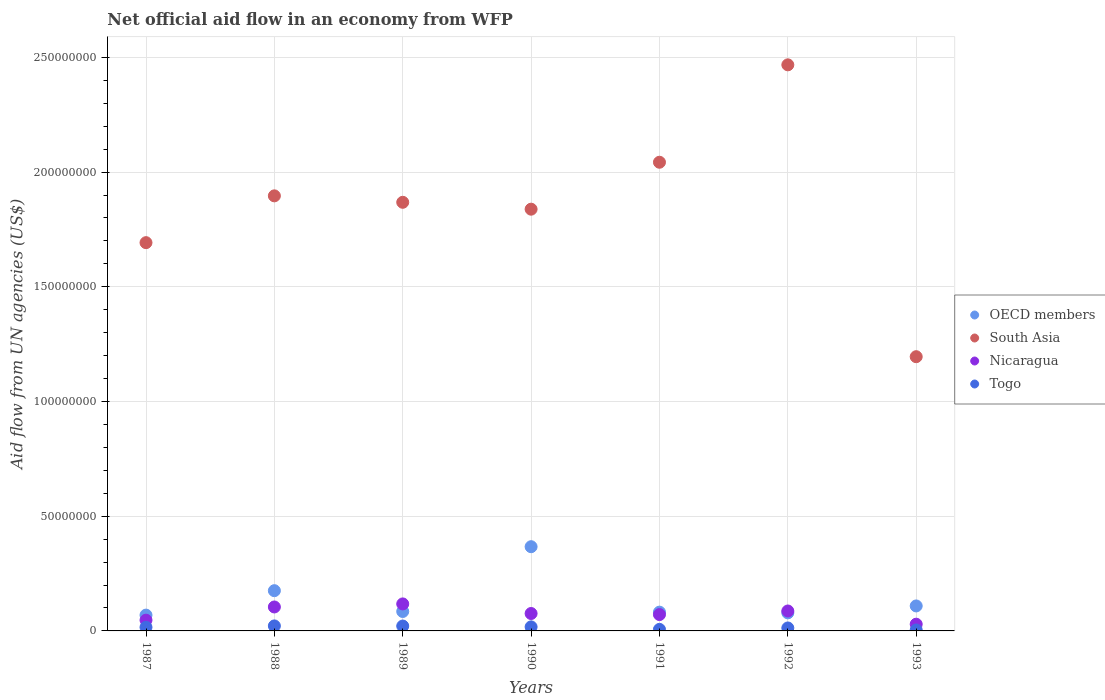What is the net official aid flow in South Asia in 1991?
Provide a short and direct response. 2.04e+08. Across all years, what is the maximum net official aid flow in South Asia?
Your answer should be compact. 2.47e+08. Across all years, what is the minimum net official aid flow in South Asia?
Give a very brief answer. 1.20e+08. In which year was the net official aid flow in Nicaragua maximum?
Your answer should be very brief. 1989. In which year was the net official aid flow in Togo minimum?
Ensure brevity in your answer.  1993. What is the total net official aid flow in Togo in the graph?
Provide a succinct answer. 1.00e+07. What is the difference between the net official aid flow in South Asia in 1988 and that in 1990?
Keep it short and to the point. 5.81e+06. What is the difference between the net official aid flow in Nicaragua in 1992 and the net official aid flow in South Asia in 1990?
Offer a terse response. -1.75e+08. What is the average net official aid flow in OECD members per year?
Give a very brief answer. 1.38e+07. In the year 1990, what is the difference between the net official aid flow in South Asia and net official aid flow in Togo?
Provide a succinct answer. 1.82e+08. What is the ratio of the net official aid flow in Nicaragua in 1989 to that in 1991?
Give a very brief answer. 1.65. Is the net official aid flow in South Asia in 1989 less than that in 1991?
Provide a short and direct response. Yes. What is the difference between the highest and the second highest net official aid flow in OECD members?
Provide a succinct answer. 1.92e+07. What is the difference between the highest and the lowest net official aid flow in Nicaragua?
Give a very brief answer. 8.84e+06. Is the sum of the net official aid flow in OECD members in 1987 and 1991 greater than the maximum net official aid flow in Togo across all years?
Offer a terse response. Yes. Is it the case that in every year, the sum of the net official aid flow in Togo and net official aid flow in OECD members  is greater than the sum of net official aid flow in South Asia and net official aid flow in Nicaragua?
Keep it short and to the point. Yes. Is it the case that in every year, the sum of the net official aid flow in OECD members and net official aid flow in South Asia  is greater than the net official aid flow in Nicaragua?
Ensure brevity in your answer.  Yes. Is the net official aid flow in OECD members strictly greater than the net official aid flow in Togo over the years?
Ensure brevity in your answer.  Yes. How many dotlines are there?
Your response must be concise. 4. How many years are there in the graph?
Make the answer very short. 7. What is the difference between two consecutive major ticks on the Y-axis?
Offer a terse response. 5.00e+07. Does the graph contain any zero values?
Offer a very short reply. No. Does the graph contain grids?
Make the answer very short. Yes. Where does the legend appear in the graph?
Provide a succinct answer. Center right. How many legend labels are there?
Provide a succinct answer. 4. How are the legend labels stacked?
Ensure brevity in your answer.  Vertical. What is the title of the graph?
Offer a terse response. Net official aid flow in an economy from WFP. Does "Bosnia and Herzegovina" appear as one of the legend labels in the graph?
Your answer should be compact. No. What is the label or title of the Y-axis?
Offer a very short reply. Aid flow from UN agencies (US$). What is the Aid flow from UN agencies (US$) of OECD members in 1987?
Offer a very short reply. 6.89e+06. What is the Aid flow from UN agencies (US$) in South Asia in 1987?
Your answer should be compact. 1.69e+08. What is the Aid flow from UN agencies (US$) in Nicaragua in 1987?
Provide a short and direct response. 4.69e+06. What is the Aid flow from UN agencies (US$) of Togo in 1987?
Provide a short and direct response. 1.59e+06. What is the Aid flow from UN agencies (US$) in OECD members in 1988?
Give a very brief answer. 1.75e+07. What is the Aid flow from UN agencies (US$) in South Asia in 1988?
Make the answer very short. 1.90e+08. What is the Aid flow from UN agencies (US$) in Nicaragua in 1988?
Offer a terse response. 1.04e+07. What is the Aid flow from UN agencies (US$) in Togo in 1988?
Give a very brief answer. 2.18e+06. What is the Aid flow from UN agencies (US$) in OECD members in 1989?
Your response must be concise. 8.47e+06. What is the Aid flow from UN agencies (US$) of South Asia in 1989?
Ensure brevity in your answer.  1.87e+08. What is the Aid flow from UN agencies (US$) of Nicaragua in 1989?
Ensure brevity in your answer.  1.18e+07. What is the Aid flow from UN agencies (US$) of Togo in 1989?
Provide a short and direct response. 2.13e+06. What is the Aid flow from UN agencies (US$) of OECD members in 1990?
Provide a short and direct response. 3.67e+07. What is the Aid flow from UN agencies (US$) of South Asia in 1990?
Provide a short and direct response. 1.84e+08. What is the Aid flow from UN agencies (US$) of Nicaragua in 1990?
Give a very brief answer. 7.59e+06. What is the Aid flow from UN agencies (US$) of Togo in 1990?
Provide a succinct answer. 1.76e+06. What is the Aid flow from UN agencies (US$) of OECD members in 1991?
Your answer should be compact. 8.18e+06. What is the Aid flow from UN agencies (US$) of South Asia in 1991?
Your answer should be compact. 2.04e+08. What is the Aid flow from UN agencies (US$) in Nicaragua in 1991?
Offer a terse response. 7.13e+06. What is the Aid flow from UN agencies (US$) in Togo in 1991?
Provide a succinct answer. 6.70e+05. What is the Aid flow from UN agencies (US$) of OECD members in 1992?
Provide a short and direct response. 7.87e+06. What is the Aid flow from UN agencies (US$) in South Asia in 1992?
Offer a terse response. 2.47e+08. What is the Aid flow from UN agencies (US$) of Nicaragua in 1992?
Give a very brief answer. 8.69e+06. What is the Aid flow from UN agencies (US$) of Togo in 1992?
Your response must be concise. 1.29e+06. What is the Aid flow from UN agencies (US$) in OECD members in 1993?
Your answer should be compact. 1.09e+07. What is the Aid flow from UN agencies (US$) in South Asia in 1993?
Your answer should be compact. 1.20e+08. What is the Aid flow from UN agencies (US$) in Nicaragua in 1993?
Your answer should be compact. 2.93e+06. What is the Aid flow from UN agencies (US$) of Togo in 1993?
Your answer should be compact. 4.20e+05. Across all years, what is the maximum Aid flow from UN agencies (US$) of OECD members?
Your answer should be very brief. 3.67e+07. Across all years, what is the maximum Aid flow from UN agencies (US$) in South Asia?
Ensure brevity in your answer.  2.47e+08. Across all years, what is the maximum Aid flow from UN agencies (US$) of Nicaragua?
Provide a short and direct response. 1.18e+07. Across all years, what is the maximum Aid flow from UN agencies (US$) in Togo?
Make the answer very short. 2.18e+06. Across all years, what is the minimum Aid flow from UN agencies (US$) in OECD members?
Provide a succinct answer. 6.89e+06. Across all years, what is the minimum Aid flow from UN agencies (US$) of South Asia?
Keep it short and to the point. 1.20e+08. Across all years, what is the minimum Aid flow from UN agencies (US$) in Nicaragua?
Provide a succinct answer. 2.93e+06. Across all years, what is the minimum Aid flow from UN agencies (US$) of Togo?
Your answer should be compact. 4.20e+05. What is the total Aid flow from UN agencies (US$) in OECD members in the graph?
Make the answer very short. 9.66e+07. What is the total Aid flow from UN agencies (US$) of South Asia in the graph?
Provide a short and direct response. 1.30e+09. What is the total Aid flow from UN agencies (US$) of Nicaragua in the graph?
Keep it short and to the point. 5.32e+07. What is the total Aid flow from UN agencies (US$) of Togo in the graph?
Your answer should be very brief. 1.00e+07. What is the difference between the Aid flow from UN agencies (US$) of OECD members in 1987 and that in 1988?
Your response must be concise. -1.06e+07. What is the difference between the Aid flow from UN agencies (US$) in South Asia in 1987 and that in 1988?
Offer a very short reply. -2.04e+07. What is the difference between the Aid flow from UN agencies (US$) in Nicaragua in 1987 and that in 1988?
Provide a succinct answer. -5.75e+06. What is the difference between the Aid flow from UN agencies (US$) in Togo in 1987 and that in 1988?
Make the answer very short. -5.90e+05. What is the difference between the Aid flow from UN agencies (US$) in OECD members in 1987 and that in 1989?
Ensure brevity in your answer.  -1.58e+06. What is the difference between the Aid flow from UN agencies (US$) in South Asia in 1987 and that in 1989?
Provide a succinct answer. -1.76e+07. What is the difference between the Aid flow from UN agencies (US$) in Nicaragua in 1987 and that in 1989?
Your answer should be compact. -7.08e+06. What is the difference between the Aid flow from UN agencies (US$) of Togo in 1987 and that in 1989?
Provide a short and direct response. -5.40e+05. What is the difference between the Aid flow from UN agencies (US$) of OECD members in 1987 and that in 1990?
Ensure brevity in your answer.  -2.98e+07. What is the difference between the Aid flow from UN agencies (US$) of South Asia in 1987 and that in 1990?
Your answer should be very brief. -1.46e+07. What is the difference between the Aid flow from UN agencies (US$) of Nicaragua in 1987 and that in 1990?
Provide a succinct answer. -2.90e+06. What is the difference between the Aid flow from UN agencies (US$) of Togo in 1987 and that in 1990?
Your answer should be compact. -1.70e+05. What is the difference between the Aid flow from UN agencies (US$) of OECD members in 1987 and that in 1991?
Provide a short and direct response. -1.29e+06. What is the difference between the Aid flow from UN agencies (US$) of South Asia in 1987 and that in 1991?
Your answer should be very brief. -3.50e+07. What is the difference between the Aid flow from UN agencies (US$) in Nicaragua in 1987 and that in 1991?
Offer a terse response. -2.44e+06. What is the difference between the Aid flow from UN agencies (US$) in Togo in 1987 and that in 1991?
Provide a succinct answer. 9.20e+05. What is the difference between the Aid flow from UN agencies (US$) of OECD members in 1987 and that in 1992?
Give a very brief answer. -9.80e+05. What is the difference between the Aid flow from UN agencies (US$) of South Asia in 1987 and that in 1992?
Provide a succinct answer. -7.75e+07. What is the difference between the Aid flow from UN agencies (US$) of Nicaragua in 1987 and that in 1992?
Offer a terse response. -4.00e+06. What is the difference between the Aid flow from UN agencies (US$) of South Asia in 1987 and that in 1993?
Your answer should be compact. 4.97e+07. What is the difference between the Aid flow from UN agencies (US$) in Nicaragua in 1987 and that in 1993?
Keep it short and to the point. 1.76e+06. What is the difference between the Aid flow from UN agencies (US$) of Togo in 1987 and that in 1993?
Keep it short and to the point. 1.17e+06. What is the difference between the Aid flow from UN agencies (US$) in OECD members in 1988 and that in 1989?
Provide a succinct answer. 9.07e+06. What is the difference between the Aid flow from UN agencies (US$) in South Asia in 1988 and that in 1989?
Offer a very short reply. 2.81e+06. What is the difference between the Aid flow from UN agencies (US$) in Nicaragua in 1988 and that in 1989?
Offer a terse response. -1.33e+06. What is the difference between the Aid flow from UN agencies (US$) in OECD members in 1988 and that in 1990?
Offer a terse response. -1.92e+07. What is the difference between the Aid flow from UN agencies (US$) in South Asia in 1988 and that in 1990?
Your answer should be compact. 5.81e+06. What is the difference between the Aid flow from UN agencies (US$) in Nicaragua in 1988 and that in 1990?
Keep it short and to the point. 2.85e+06. What is the difference between the Aid flow from UN agencies (US$) in Togo in 1988 and that in 1990?
Your answer should be very brief. 4.20e+05. What is the difference between the Aid flow from UN agencies (US$) in OECD members in 1988 and that in 1991?
Offer a very short reply. 9.36e+06. What is the difference between the Aid flow from UN agencies (US$) in South Asia in 1988 and that in 1991?
Make the answer very short. -1.46e+07. What is the difference between the Aid flow from UN agencies (US$) in Nicaragua in 1988 and that in 1991?
Ensure brevity in your answer.  3.31e+06. What is the difference between the Aid flow from UN agencies (US$) in Togo in 1988 and that in 1991?
Make the answer very short. 1.51e+06. What is the difference between the Aid flow from UN agencies (US$) in OECD members in 1988 and that in 1992?
Make the answer very short. 9.67e+06. What is the difference between the Aid flow from UN agencies (US$) in South Asia in 1988 and that in 1992?
Ensure brevity in your answer.  -5.71e+07. What is the difference between the Aid flow from UN agencies (US$) in Nicaragua in 1988 and that in 1992?
Your answer should be very brief. 1.75e+06. What is the difference between the Aid flow from UN agencies (US$) of Togo in 1988 and that in 1992?
Give a very brief answer. 8.90e+05. What is the difference between the Aid flow from UN agencies (US$) in OECD members in 1988 and that in 1993?
Offer a very short reply. 6.65e+06. What is the difference between the Aid flow from UN agencies (US$) of South Asia in 1988 and that in 1993?
Your answer should be very brief. 7.01e+07. What is the difference between the Aid flow from UN agencies (US$) of Nicaragua in 1988 and that in 1993?
Give a very brief answer. 7.51e+06. What is the difference between the Aid flow from UN agencies (US$) in Togo in 1988 and that in 1993?
Offer a terse response. 1.76e+06. What is the difference between the Aid flow from UN agencies (US$) of OECD members in 1989 and that in 1990?
Your answer should be very brief. -2.82e+07. What is the difference between the Aid flow from UN agencies (US$) of Nicaragua in 1989 and that in 1990?
Provide a short and direct response. 4.18e+06. What is the difference between the Aid flow from UN agencies (US$) of Togo in 1989 and that in 1990?
Offer a very short reply. 3.70e+05. What is the difference between the Aid flow from UN agencies (US$) in South Asia in 1989 and that in 1991?
Keep it short and to the point. -1.75e+07. What is the difference between the Aid flow from UN agencies (US$) in Nicaragua in 1989 and that in 1991?
Your response must be concise. 4.64e+06. What is the difference between the Aid flow from UN agencies (US$) in Togo in 1989 and that in 1991?
Your response must be concise. 1.46e+06. What is the difference between the Aid flow from UN agencies (US$) in South Asia in 1989 and that in 1992?
Your answer should be compact. -5.99e+07. What is the difference between the Aid flow from UN agencies (US$) of Nicaragua in 1989 and that in 1992?
Ensure brevity in your answer.  3.08e+06. What is the difference between the Aid flow from UN agencies (US$) in Togo in 1989 and that in 1992?
Your answer should be very brief. 8.40e+05. What is the difference between the Aid flow from UN agencies (US$) of OECD members in 1989 and that in 1993?
Offer a terse response. -2.42e+06. What is the difference between the Aid flow from UN agencies (US$) in South Asia in 1989 and that in 1993?
Your response must be concise. 6.73e+07. What is the difference between the Aid flow from UN agencies (US$) in Nicaragua in 1989 and that in 1993?
Your answer should be very brief. 8.84e+06. What is the difference between the Aid flow from UN agencies (US$) of Togo in 1989 and that in 1993?
Give a very brief answer. 1.71e+06. What is the difference between the Aid flow from UN agencies (US$) of OECD members in 1990 and that in 1991?
Provide a short and direct response. 2.85e+07. What is the difference between the Aid flow from UN agencies (US$) of South Asia in 1990 and that in 1991?
Keep it short and to the point. -2.05e+07. What is the difference between the Aid flow from UN agencies (US$) of Nicaragua in 1990 and that in 1991?
Provide a succinct answer. 4.60e+05. What is the difference between the Aid flow from UN agencies (US$) of Togo in 1990 and that in 1991?
Provide a short and direct response. 1.09e+06. What is the difference between the Aid flow from UN agencies (US$) in OECD members in 1990 and that in 1992?
Keep it short and to the point. 2.88e+07. What is the difference between the Aid flow from UN agencies (US$) of South Asia in 1990 and that in 1992?
Your answer should be very brief. -6.29e+07. What is the difference between the Aid flow from UN agencies (US$) of Nicaragua in 1990 and that in 1992?
Provide a succinct answer. -1.10e+06. What is the difference between the Aid flow from UN agencies (US$) in Togo in 1990 and that in 1992?
Provide a short and direct response. 4.70e+05. What is the difference between the Aid flow from UN agencies (US$) of OECD members in 1990 and that in 1993?
Your answer should be very brief. 2.58e+07. What is the difference between the Aid flow from UN agencies (US$) in South Asia in 1990 and that in 1993?
Your answer should be compact. 6.43e+07. What is the difference between the Aid flow from UN agencies (US$) of Nicaragua in 1990 and that in 1993?
Make the answer very short. 4.66e+06. What is the difference between the Aid flow from UN agencies (US$) of Togo in 1990 and that in 1993?
Make the answer very short. 1.34e+06. What is the difference between the Aid flow from UN agencies (US$) in OECD members in 1991 and that in 1992?
Offer a very short reply. 3.10e+05. What is the difference between the Aid flow from UN agencies (US$) of South Asia in 1991 and that in 1992?
Give a very brief answer. -4.25e+07. What is the difference between the Aid flow from UN agencies (US$) of Nicaragua in 1991 and that in 1992?
Keep it short and to the point. -1.56e+06. What is the difference between the Aid flow from UN agencies (US$) of Togo in 1991 and that in 1992?
Offer a very short reply. -6.20e+05. What is the difference between the Aid flow from UN agencies (US$) in OECD members in 1991 and that in 1993?
Provide a succinct answer. -2.71e+06. What is the difference between the Aid flow from UN agencies (US$) of South Asia in 1991 and that in 1993?
Offer a very short reply. 8.48e+07. What is the difference between the Aid flow from UN agencies (US$) of Nicaragua in 1991 and that in 1993?
Make the answer very short. 4.20e+06. What is the difference between the Aid flow from UN agencies (US$) in Togo in 1991 and that in 1993?
Offer a very short reply. 2.50e+05. What is the difference between the Aid flow from UN agencies (US$) of OECD members in 1992 and that in 1993?
Provide a short and direct response. -3.02e+06. What is the difference between the Aid flow from UN agencies (US$) in South Asia in 1992 and that in 1993?
Make the answer very short. 1.27e+08. What is the difference between the Aid flow from UN agencies (US$) in Nicaragua in 1992 and that in 1993?
Give a very brief answer. 5.76e+06. What is the difference between the Aid flow from UN agencies (US$) in Togo in 1992 and that in 1993?
Your response must be concise. 8.70e+05. What is the difference between the Aid flow from UN agencies (US$) in OECD members in 1987 and the Aid flow from UN agencies (US$) in South Asia in 1988?
Ensure brevity in your answer.  -1.83e+08. What is the difference between the Aid flow from UN agencies (US$) in OECD members in 1987 and the Aid flow from UN agencies (US$) in Nicaragua in 1988?
Your answer should be very brief. -3.55e+06. What is the difference between the Aid flow from UN agencies (US$) in OECD members in 1987 and the Aid flow from UN agencies (US$) in Togo in 1988?
Your answer should be compact. 4.71e+06. What is the difference between the Aid flow from UN agencies (US$) in South Asia in 1987 and the Aid flow from UN agencies (US$) in Nicaragua in 1988?
Offer a very short reply. 1.59e+08. What is the difference between the Aid flow from UN agencies (US$) of South Asia in 1987 and the Aid flow from UN agencies (US$) of Togo in 1988?
Give a very brief answer. 1.67e+08. What is the difference between the Aid flow from UN agencies (US$) of Nicaragua in 1987 and the Aid flow from UN agencies (US$) of Togo in 1988?
Give a very brief answer. 2.51e+06. What is the difference between the Aid flow from UN agencies (US$) in OECD members in 1987 and the Aid flow from UN agencies (US$) in South Asia in 1989?
Your response must be concise. -1.80e+08. What is the difference between the Aid flow from UN agencies (US$) in OECD members in 1987 and the Aid flow from UN agencies (US$) in Nicaragua in 1989?
Provide a succinct answer. -4.88e+06. What is the difference between the Aid flow from UN agencies (US$) in OECD members in 1987 and the Aid flow from UN agencies (US$) in Togo in 1989?
Ensure brevity in your answer.  4.76e+06. What is the difference between the Aid flow from UN agencies (US$) of South Asia in 1987 and the Aid flow from UN agencies (US$) of Nicaragua in 1989?
Your response must be concise. 1.57e+08. What is the difference between the Aid flow from UN agencies (US$) of South Asia in 1987 and the Aid flow from UN agencies (US$) of Togo in 1989?
Provide a succinct answer. 1.67e+08. What is the difference between the Aid flow from UN agencies (US$) of Nicaragua in 1987 and the Aid flow from UN agencies (US$) of Togo in 1989?
Provide a short and direct response. 2.56e+06. What is the difference between the Aid flow from UN agencies (US$) of OECD members in 1987 and the Aid flow from UN agencies (US$) of South Asia in 1990?
Give a very brief answer. -1.77e+08. What is the difference between the Aid flow from UN agencies (US$) in OECD members in 1987 and the Aid flow from UN agencies (US$) in Nicaragua in 1990?
Make the answer very short. -7.00e+05. What is the difference between the Aid flow from UN agencies (US$) in OECD members in 1987 and the Aid flow from UN agencies (US$) in Togo in 1990?
Your answer should be compact. 5.13e+06. What is the difference between the Aid flow from UN agencies (US$) in South Asia in 1987 and the Aid flow from UN agencies (US$) in Nicaragua in 1990?
Provide a short and direct response. 1.62e+08. What is the difference between the Aid flow from UN agencies (US$) of South Asia in 1987 and the Aid flow from UN agencies (US$) of Togo in 1990?
Your answer should be compact. 1.67e+08. What is the difference between the Aid flow from UN agencies (US$) of Nicaragua in 1987 and the Aid flow from UN agencies (US$) of Togo in 1990?
Offer a terse response. 2.93e+06. What is the difference between the Aid flow from UN agencies (US$) of OECD members in 1987 and the Aid flow from UN agencies (US$) of South Asia in 1991?
Keep it short and to the point. -1.97e+08. What is the difference between the Aid flow from UN agencies (US$) in OECD members in 1987 and the Aid flow from UN agencies (US$) in Togo in 1991?
Make the answer very short. 6.22e+06. What is the difference between the Aid flow from UN agencies (US$) in South Asia in 1987 and the Aid flow from UN agencies (US$) in Nicaragua in 1991?
Offer a very short reply. 1.62e+08. What is the difference between the Aid flow from UN agencies (US$) of South Asia in 1987 and the Aid flow from UN agencies (US$) of Togo in 1991?
Give a very brief answer. 1.69e+08. What is the difference between the Aid flow from UN agencies (US$) of Nicaragua in 1987 and the Aid flow from UN agencies (US$) of Togo in 1991?
Keep it short and to the point. 4.02e+06. What is the difference between the Aid flow from UN agencies (US$) in OECD members in 1987 and the Aid flow from UN agencies (US$) in South Asia in 1992?
Give a very brief answer. -2.40e+08. What is the difference between the Aid flow from UN agencies (US$) in OECD members in 1987 and the Aid flow from UN agencies (US$) in Nicaragua in 1992?
Keep it short and to the point. -1.80e+06. What is the difference between the Aid flow from UN agencies (US$) of OECD members in 1987 and the Aid flow from UN agencies (US$) of Togo in 1992?
Ensure brevity in your answer.  5.60e+06. What is the difference between the Aid flow from UN agencies (US$) in South Asia in 1987 and the Aid flow from UN agencies (US$) in Nicaragua in 1992?
Your answer should be very brief. 1.61e+08. What is the difference between the Aid flow from UN agencies (US$) in South Asia in 1987 and the Aid flow from UN agencies (US$) in Togo in 1992?
Make the answer very short. 1.68e+08. What is the difference between the Aid flow from UN agencies (US$) in Nicaragua in 1987 and the Aid flow from UN agencies (US$) in Togo in 1992?
Give a very brief answer. 3.40e+06. What is the difference between the Aid flow from UN agencies (US$) of OECD members in 1987 and the Aid flow from UN agencies (US$) of South Asia in 1993?
Provide a succinct answer. -1.13e+08. What is the difference between the Aid flow from UN agencies (US$) in OECD members in 1987 and the Aid flow from UN agencies (US$) in Nicaragua in 1993?
Provide a succinct answer. 3.96e+06. What is the difference between the Aid flow from UN agencies (US$) in OECD members in 1987 and the Aid flow from UN agencies (US$) in Togo in 1993?
Ensure brevity in your answer.  6.47e+06. What is the difference between the Aid flow from UN agencies (US$) in South Asia in 1987 and the Aid flow from UN agencies (US$) in Nicaragua in 1993?
Make the answer very short. 1.66e+08. What is the difference between the Aid flow from UN agencies (US$) in South Asia in 1987 and the Aid flow from UN agencies (US$) in Togo in 1993?
Provide a short and direct response. 1.69e+08. What is the difference between the Aid flow from UN agencies (US$) in Nicaragua in 1987 and the Aid flow from UN agencies (US$) in Togo in 1993?
Provide a short and direct response. 4.27e+06. What is the difference between the Aid flow from UN agencies (US$) in OECD members in 1988 and the Aid flow from UN agencies (US$) in South Asia in 1989?
Give a very brief answer. -1.69e+08. What is the difference between the Aid flow from UN agencies (US$) in OECD members in 1988 and the Aid flow from UN agencies (US$) in Nicaragua in 1989?
Your response must be concise. 5.77e+06. What is the difference between the Aid flow from UN agencies (US$) of OECD members in 1988 and the Aid flow from UN agencies (US$) of Togo in 1989?
Your answer should be compact. 1.54e+07. What is the difference between the Aid flow from UN agencies (US$) in South Asia in 1988 and the Aid flow from UN agencies (US$) in Nicaragua in 1989?
Keep it short and to the point. 1.78e+08. What is the difference between the Aid flow from UN agencies (US$) of South Asia in 1988 and the Aid flow from UN agencies (US$) of Togo in 1989?
Keep it short and to the point. 1.88e+08. What is the difference between the Aid flow from UN agencies (US$) of Nicaragua in 1988 and the Aid flow from UN agencies (US$) of Togo in 1989?
Keep it short and to the point. 8.31e+06. What is the difference between the Aid flow from UN agencies (US$) in OECD members in 1988 and the Aid flow from UN agencies (US$) in South Asia in 1990?
Give a very brief answer. -1.66e+08. What is the difference between the Aid flow from UN agencies (US$) of OECD members in 1988 and the Aid flow from UN agencies (US$) of Nicaragua in 1990?
Keep it short and to the point. 9.95e+06. What is the difference between the Aid flow from UN agencies (US$) of OECD members in 1988 and the Aid flow from UN agencies (US$) of Togo in 1990?
Keep it short and to the point. 1.58e+07. What is the difference between the Aid flow from UN agencies (US$) in South Asia in 1988 and the Aid flow from UN agencies (US$) in Nicaragua in 1990?
Keep it short and to the point. 1.82e+08. What is the difference between the Aid flow from UN agencies (US$) of South Asia in 1988 and the Aid flow from UN agencies (US$) of Togo in 1990?
Offer a terse response. 1.88e+08. What is the difference between the Aid flow from UN agencies (US$) of Nicaragua in 1988 and the Aid flow from UN agencies (US$) of Togo in 1990?
Your response must be concise. 8.68e+06. What is the difference between the Aid flow from UN agencies (US$) in OECD members in 1988 and the Aid flow from UN agencies (US$) in South Asia in 1991?
Keep it short and to the point. -1.87e+08. What is the difference between the Aid flow from UN agencies (US$) of OECD members in 1988 and the Aid flow from UN agencies (US$) of Nicaragua in 1991?
Offer a very short reply. 1.04e+07. What is the difference between the Aid flow from UN agencies (US$) in OECD members in 1988 and the Aid flow from UN agencies (US$) in Togo in 1991?
Provide a short and direct response. 1.69e+07. What is the difference between the Aid flow from UN agencies (US$) in South Asia in 1988 and the Aid flow from UN agencies (US$) in Nicaragua in 1991?
Make the answer very short. 1.83e+08. What is the difference between the Aid flow from UN agencies (US$) in South Asia in 1988 and the Aid flow from UN agencies (US$) in Togo in 1991?
Ensure brevity in your answer.  1.89e+08. What is the difference between the Aid flow from UN agencies (US$) of Nicaragua in 1988 and the Aid flow from UN agencies (US$) of Togo in 1991?
Make the answer very short. 9.77e+06. What is the difference between the Aid flow from UN agencies (US$) in OECD members in 1988 and the Aid flow from UN agencies (US$) in South Asia in 1992?
Offer a very short reply. -2.29e+08. What is the difference between the Aid flow from UN agencies (US$) of OECD members in 1988 and the Aid flow from UN agencies (US$) of Nicaragua in 1992?
Your response must be concise. 8.85e+06. What is the difference between the Aid flow from UN agencies (US$) in OECD members in 1988 and the Aid flow from UN agencies (US$) in Togo in 1992?
Your response must be concise. 1.62e+07. What is the difference between the Aid flow from UN agencies (US$) in South Asia in 1988 and the Aid flow from UN agencies (US$) in Nicaragua in 1992?
Keep it short and to the point. 1.81e+08. What is the difference between the Aid flow from UN agencies (US$) of South Asia in 1988 and the Aid flow from UN agencies (US$) of Togo in 1992?
Give a very brief answer. 1.88e+08. What is the difference between the Aid flow from UN agencies (US$) of Nicaragua in 1988 and the Aid flow from UN agencies (US$) of Togo in 1992?
Your answer should be compact. 9.15e+06. What is the difference between the Aid flow from UN agencies (US$) of OECD members in 1988 and the Aid flow from UN agencies (US$) of South Asia in 1993?
Your answer should be very brief. -1.02e+08. What is the difference between the Aid flow from UN agencies (US$) of OECD members in 1988 and the Aid flow from UN agencies (US$) of Nicaragua in 1993?
Your answer should be very brief. 1.46e+07. What is the difference between the Aid flow from UN agencies (US$) of OECD members in 1988 and the Aid flow from UN agencies (US$) of Togo in 1993?
Provide a succinct answer. 1.71e+07. What is the difference between the Aid flow from UN agencies (US$) in South Asia in 1988 and the Aid flow from UN agencies (US$) in Nicaragua in 1993?
Keep it short and to the point. 1.87e+08. What is the difference between the Aid flow from UN agencies (US$) of South Asia in 1988 and the Aid flow from UN agencies (US$) of Togo in 1993?
Keep it short and to the point. 1.89e+08. What is the difference between the Aid flow from UN agencies (US$) of Nicaragua in 1988 and the Aid flow from UN agencies (US$) of Togo in 1993?
Your answer should be compact. 1.00e+07. What is the difference between the Aid flow from UN agencies (US$) of OECD members in 1989 and the Aid flow from UN agencies (US$) of South Asia in 1990?
Provide a succinct answer. -1.75e+08. What is the difference between the Aid flow from UN agencies (US$) of OECD members in 1989 and the Aid flow from UN agencies (US$) of Nicaragua in 1990?
Provide a short and direct response. 8.80e+05. What is the difference between the Aid flow from UN agencies (US$) of OECD members in 1989 and the Aid flow from UN agencies (US$) of Togo in 1990?
Provide a short and direct response. 6.71e+06. What is the difference between the Aid flow from UN agencies (US$) in South Asia in 1989 and the Aid flow from UN agencies (US$) in Nicaragua in 1990?
Your answer should be compact. 1.79e+08. What is the difference between the Aid flow from UN agencies (US$) in South Asia in 1989 and the Aid flow from UN agencies (US$) in Togo in 1990?
Your answer should be very brief. 1.85e+08. What is the difference between the Aid flow from UN agencies (US$) of Nicaragua in 1989 and the Aid flow from UN agencies (US$) of Togo in 1990?
Ensure brevity in your answer.  1.00e+07. What is the difference between the Aid flow from UN agencies (US$) in OECD members in 1989 and the Aid flow from UN agencies (US$) in South Asia in 1991?
Your answer should be compact. -1.96e+08. What is the difference between the Aid flow from UN agencies (US$) of OECD members in 1989 and the Aid flow from UN agencies (US$) of Nicaragua in 1991?
Ensure brevity in your answer.  1.34e+06. What is the difference between the Aid flow from UN agencies (US$) of OECD members in 1989 and the Aid flow from UN agencies (US$) of Togo in 1991?
Ensure brevity in your answer.  7.80e+06. What is the difference between the Aid flow from UN agencies (US$) of South Asia in 1989 and the Aid flow from UN agencies (US$) of Nicaragua in 1991?
Your response must be concise. 1.80e+08. What is the difference between the Aid flow from UN agencies (US$) of South Asia in 1989 and the Aid flow from UN agencies (US$) of Togo in 1991?
Keep it short and to the point. 1.86e+08. What is the difference between the Aid flow from UN agencies (US$) in Nicaragua in 1989 and the Aid flow from UN agencies (US$) in Togo in 1991?
Offer a terse response. 1.11e+07. What is the difference between the Aid flow from UN agencies (US$) of OECD members in 1989 and the Aid flow from UN agencies (US$) of South Asia in 1992?
Your answer should be compact. -2.38e+08. What is the difference between the Aid flow from UN agencies (US$) of OECD members in 1989 and the Aid flow from UN agencies (US$) of Nicaragua in 1992?
Provide a short and direct response. -2.20e+05. What is the difference between the Aid flow from UN agencies (US$) in OECD members in 1989 and the Aid flow from UN agencies (US$) in Togo in 1992?
Your answer should be very brief. 7.18e+06. What is the difference between the Aid flow from UN agencies (US$) of South Asia in 1989 and the Aid flow from UN agencies (US$) of Nicaragua in 1992?
Provide a short and direct response. 1.78e+08. What is the difference between the Aid flow from UN agencies (US$) of South Asia in 1989 and the Aid flow from UN agencies (US$) of Togo in 1992?
Provide a succinct answer. 1.86e+08. What is the difference between the Aid flow from UN agencies (US$) in Nicaragua in 1989 and the Aid flow from UN agencies (US$) in Togo in 1992?
Offer a terse response. 1.05e+07. What is the difference between the Aid flow from UN agencies (US$) in OECD members in 1989 and the Aid flow from UN agencies (US$) in South Asia in 1993?
Ensure brevity in your answer.  -1.11e+08. What is the difference between the Aid flow from UN agencies (US$) in OECD members in 1989 and the Aid flow from UN agencies (US$) in Nicaragua in 1993?
Ensure brevity in your answer.  5.54e+06. What is the difference between the Aid flow from UN agencies (US$) of OECD members in 1989 and the Aid flow from UN agencies (US$) of Togo in 1993?
Your answer should be very brief. 8.05e+06. What is the difference between the Aid flow from UN agencies (US$) in South Asia in 1989 and the Aid flow from UN agencies (US$) in Nicaragua in 1993?
Keep it short and to the point. 1.84e+08. What is the difference between the Aid flow from UN agencies (US$) of South Asia in 1989 and the Aid flow from UN agencies (US$) of Togo in 1993?
Offer a terse response. 1.86e+08. What is the difference between the Aid flow from UN agencies (US$) of Nicaragua in 1989 and the Aid flow from UN agencies (US$) of Togo in 1993?
Ensure brevity in your answer.  1.14e+07. What is the difference between the Aid flow from UN agencies (US$) in OECD members in 1990 and the Aid flow from UN agencies (US$) in South Asia in 1991?
Provide a succinct answer. -1.68e+08. What is the difference between the Aid flow from UN agencies (US$) in OECD members in 1990 and the Aid flow from UN agencies (US$) in Nicaragua in 1991?
Offer a terse response. 2.96e+07. What is the difference between the Aid flow from UN agencies (US$) in OECD members in 1990 and the Aid flow from UN agencies (US$) in Togo in 1991?
Make the answer very short. 3.60e+07. What is the difference between the Aid flow from UN agencies (US$) of South Asia in 1990 and the Aid flow from UN agencies (US$) of Nicaragua in 1991?
Give a very brief answer. 1.77e+08. What is the difference between the Aid flow from UN agencies (US$) in South Asia in 1990 and the Aid flow from UN agencies (US$) in Togo in 1991?
Provide a succinct answer. 1.83e+08. What is the difference between the Aid flow from UN agencies (US$) in Nicaragua in 1990 and the Aid flow from UN agencies (US$) in Togo in 1991?
Ensure brevity in your answer.  6.92e+06. What is the difference between the Aid flow from UN agencies (US$) of OECD members in 1990 and the Aid flow from UN agencies (US$) of South Asia in 1992?
Your answer should be very brief. -2.10e+08. What is the difference between the Aid flow from UN agencies (US$) in OECD members in 1990 and the Aid flow from UN agencies (US$) in Nicaragua in 1992?
Offer a very short reply. 2.80e+07. What is the difference between the Aid flow from UN agencies (US$) in OECD members in 1990 and the Aid flow from UN agencies (US$) in Togo in 1992?
Your response must be concise. 3.54e+07. What is the difference between the Aid flow from UN agencies (US$) in South Asia in 1990 and the Aid flow from UN agencies (US$) in Nicaragua in 1992?
Offer a terse response. 1.75e+08. What is the difference between the Aid flow from UN agencies (US$) in South Asia in 1990 and the Aid flow from UN agencies (US$) in Togo in 1992?
Make the answer very short. 1.83e+08. What is the difference between the Aid flow from UN agencies (US$) in Nicaragua in 1990 and the Aid flow from UN agencies (US$) in Togo in 1992?
Your response must be concise. 6.30e+06. What is the difference between the Aid flow from UN agencies (US$) of OECD members in 1990 and the Aid flow from UN agencies (US$) of South Asia in 1993?
Your response must be concise. -8.28e+07. What is the difference between the Aid flow from UN agencies (US$) of OECD members in 1990 and the Aid flow from UN agencies (US$) of Nicaragua in 1993?
Give a very brief answer. 3.38e+07. What is the difference between the Aid flow from UN agencies (US$) in OECD members in 1990 and the Aid flow from UN agencies (US$) in Togo in 1993?
Offer a terse response. 3.63e+07. What is the difference between the Aid flow from UN agencies (US$) in South Asia in 1990 and the Aid flow from UN agencies (US$) in Nicaragua in 1993?
Give a very brief answer. 1.81e+08. What is the difference between the Aid flow from UN agencies (US$) in South Asia in 1990 and the Aid flow from UN agencies (US$) in Togo in 1993?
Your response must be concise. 1.83e+08. What is the difference between the Aid flow from UN agencies (US$) in Nicaragua in 1990 and the Aid flow from UN agencies (US$) in Togo in 1993?
Make the answer very short. 7.17e+06. What is the difference between the Aid flow from UN agencies (US$) of OECD members in 1991 and the Aid flow from UN agencies (US$) of South Asia in 1992?
Make the answer very short. -2.39e+08. What is the difference between the Aid flow from UN agencies (US$) of OECD members in 1991 and the Aid flow from UN agencies (US$) of Nicaragua in 1992?
Your response must be concise. -5.10e+05. What is the difference between the Aid flow from UN agencies (US$) of OECD members in 1991 and the Aid flow from UN agencies (US$) of Togo in 1992?
Ensure brevity in your answer.  6.89e+06. What is the difference between the Aid flow from UN agencies (US$) in South Asia in 1991 and the Aid flow from UN agencies (US$) in Nicaragua in 1992?
Provide a short and direct response. 1.96e+08. What is the difference between the Aid flow from UN agencies (US$) in South Asia in 1991 and the Aid flow from UN agencies (US$) in Togo in 1992?
Your response must be concise. 2.03e+08. What is the difference between the Aid flow from UN agencies (US$) of Nicaragua in 1991 and the Aid flow from UN agencies (US$) of Togo in 1992?
Keep it short and to the point. 5.84e+06. What is the difference between the Aid flow from UN agencies (US$) of OECD members in 1991 and the Aid flow from UN agencies (US$) of South Asia in 1993?
Your response must be concise. -1.11e+08. What is the difference between the Aid flow from UN agencies (US$) in OECD members in 1991 and the Aid flow from UN agencies (US$) in Nicaragua in 1993?
Give a very brief answer. 5.25e+06. What is the difference between the Aid flow from UN agencies (US$) in OECD members in 1991 and the Aid flow from UN agencies (US$) in Togo in 1993?
Your answer should be compact. 7.76e+06. What is the difference between the Aid flow from UN agencies (US$) of South Asia in 1991 and the Aid flow from UN agencies (US$) of Nicaragua in 1993?
Make the answer very short. 2.01e+08. What is the difference between the Aid flow from UN agencies (US$) in South Asia in 1991 and the Aid flow from UN agencies (US$) in Togo in 1993?
Offer a very short reply. 2.04e+08. What is the difference between the Aid flow from UN agencies (US$) in Nicaragua in 1991 and the Aid flow from UN agencies (US$) in Togo in 1993?
Make the answer very short. 6.71e+06. What is the difference between the Aid flow from UN agencies (US$) of OECD members in 1992 and the Aid flow from UN agencies (US$) of South Asia in 1993?
Make the answer very short. -1.12e+08. What is the difference between the Aid flow from UN agencies (US$) of OECD members in 1992 and the Aid flow from UN agencies (US$) of Nicaragua in 1993?
Provide a succinct answer. 4.94e+06. What is the difference between the Aid flow from UN agencies (US$) in OECD members in 1992 and the Aid flow from UN agencies (US$) in Togo in 1993?
Your response must be concise. 7.45e+06. What is the difference between the Aid flow from UN agencies (US$) in South Asia in 1992 and the Aid flow from UN agencies (US$) in Nicaragua in 1993?
Make the answer very short. 2.44e+08. What is the difference between the Aid flow from UN agencies (US$) in South Asia in 1992 and the Aid flow from UN agencies (US$) in Togo in 1993?
Offer a terse response. 2.46e+08. What is the difference between the Aid flow from UN agencies (US$) of Nicaragua in 1992 and the Aid flow from UN agencies (US$) of Togo in 1993?
Make the answer very short. 8.27e+06. What is the average Aid flow from UN agencies (US$) in OECD members per year?
Keep it short and to the point. 1.38e+07. What is the average Aid flow from UN agencies (US$) in South Asia per year?
Provide a succinct answer. 1.86e+08. What is the average Aid flow from UN agencies (US$) of Nicaragua per year?
Provide a succinct answer. 7.61e+06. What is the average Aid flow from UN agencies (US$) of Togo per year?
Ensure brevity in your answer.  1.43e+06. In the year 1987, what is the difference between the Aid flow from UN agencies (US$) in OECD members and Aid flow from UN agencies (US$) in South Asia?
Keep it short and to the point. -1.62e+08. In the year 1987, what is the difference between the Aid flow from UN agencies (US$) of OECD members and Aid flow from UN agencies (US$) of Nicaragua?
Provide a short and direct response. 2.20e+06. In the year 1987, what is the difference between the Aid flow from UN agencies (US$) of OECD members and Aid flow from UN agencies (US$) of Togo?
Your answer should be compact. 5.30e+06. In the year 1987, what is the difference between the Aid flow from UN agencies (US$) in South Asia and Aid flow from UN agencies (US$) in Nicaragua?
Provide a short and direct response. 1.65e+08. In the year 1987, what is the difference between the Aid flow from UN agencies (US$) in South Asia and Aid flow from UN agencies (US$) in Togo?
Give a very brief answer. 1.68e+08. In the year 1987, what is the difference between the Aid flow from UN agencies (US$) in Nicaragua and Aid flow from UN agencies (US$) in Togo?
Provide a short and direct response. 3.10e+06. In the year 1988, what is the difference between the Aid flow from UN agencies (US$) in OECD members and Aid flow from UN agencies (US$) in South Asia?
Your answer should be very brief. -1.72e+08. In the year 1988, what is the difference between the Aid flow from UN agencies (US$) in OECD members and Aid flow from UN agencies (US$) in Nicaragua?
Provide a short and direct response. 7.10e+06. In the year 1988, what is the difference between the Aid flow from UN agencies (US$) in OECD members and Aid flow from UN agencies (US$) in Togo?
Make the answer very short. 1.54e+07. In the year 1988, what is the difference between the Aid flow from UN agencies (US$) of South Asia and Aid flow from UN agencies (US$) of Nicaragua?
Give a very brief answer. 1.79e+08. In the year 1988, what is the difference between the Aid flow from UN agencies (US$) of South Asia and Aid flow from UN agencies (US$) of Togo?
Offer a terse response. 1.87e+08. In the year 1988, what is the difference between the Aid flow from UN agencies (US$) in Nicaragua and Aid flow from UN agencies (US$) in Togo?
Offer a terse response. 8.26e+06. In the year 1989, what is the difference between the Aid flow from UN agencies (US$) in OECD members and Aid flow from UN agencies (US$) in South Asia?
Offer a very short reply. -1.78e+08. In the year 1989, what is the difference between the Aid flow from UN agencies (US$) of OECD members and Aid flow from UN agencies (US$) of Nicaragua?
Provide a short and direct response. -3.30e+06. In the year 1989, what is the difference between the Aid flow from UN agencies (US$) of OECD members and Aid flow from UN agencies (US$) of Togo?
Provide a succinct answer. 6.34e+06. In the year 1989, what is the difference between the Aid flow from UN agencies (US$) of South Asia and Aid flow from UN agencies (US$) of Nicaragua?
Your response must be concise. 1.75e+08. In the year 1989, what is the difference between the Aid flow from UN agencies (US$) of South Asia and Aid flow from UN agencies (US$) of Togo?
Offer a terse response. 1.85e+08. In the year 1989, what is the difference between the Aid flow from UN agencies (US$) of Nicaragua and Aid flow from UN agencies (US$) of Togo?
Provide a succinct answer. 9.64e+06. In the year 1990, what is the difference between the Aid flow from UN agencies (US$) of OECD members and Aid flow from UN agencies (US$) of South Asia?
Offer a very short reply. -1.47e+08. In the year 1990, what is the difference between the Aid flow from UN agencies (US$) of OECD members and Aid flow from UN agencies (US$) of Nicaragua?
Give a very brief answer. 2.91e+07. In the year 1990, what is the difference between the Aid flow from UN agencies (US$) in OECD members and Aid flow from UN agencies (US$) in Togo?
Offer a terse response. 3.50e+07. In the year 1990, what is the difference between the Aid flow from UN agencies (US$) of South Asia and Aid flow from UN agencies (US$) of Nicaragua?
Keep it short and to the point. 1.76e+08. In the year 1990, what is the difference between the Aid flow from UN agencies (US$) of South Asia and Aid flow from UN agencies (US$) of Togo?
Make the answer very short. 1.82e+08. In the year 1990, what is the difference between the Aid flow from UN agencies (US$) of Nicaragua and Aid flow from UN agencies (US$) of Togo?
Offer a very short reply. 5.83e+06. In the year 1991, what is the difference between the Aid flow from UN agencies (US$) of OECD members and Aid flow from UN agencies (US$) of South Asia?
Make the answer very short. -1.96e+08. In the year 1991, what is the difference between the Aid flow from UN agencies (US$) of OECD members and Aid flow from UN agencies (US$) of Nicaragua?
Make the answer very short. 1.05e+06. In the year 1991, what is the difference between the Aid flow from UN agencies (US$) in OECD members and Aid flow from UN agencies (US$) in Togo?
Provide a short and direct response. 7.51e+06. In the year 1991, what is the difference between the Aid flow from UN agencies (US$) of South Asia and Aid flow from UN agencies (US$) of Nicaragua?
Your answer should be compact. 1.97e+08. In the year 1991, what is the difference between the Aid flow from UN agencies (US$) in South Asia and Aid flow from UN agencies (US$) in Togo?
Give a very brief answer. 2.04e+08. In the year 1991, what is the difference between the Aid flow from UN agencies (US$) of Nicaragua and Aid flow from UN agencies (US$) of Togo?
Offer a terse response. 6.46e+06. In the year 1992, what is the difference between the Aid flow from UN agencies (US$) of OECD members and Aid flow from UN agencies (US$) of South Asia?
Provide a succinct answer. -2.39e+08. In the year 1992, what is the difference between the Aid flow from UN agencies (US$) of OECD members and Aid flow from UN agencies (US$) of Nicaragua?
Keep it short and to the point. -8.20e+05. In the year 1992, what is the difference between the Aid flow from UN agencies (US$) in OECD members and Aid flow from UN agencies (US$) in Togo?
Offer a very short reply. 6.58e+06. In the year 1992, what is the difference between the Aid flow from UN agencies (US$) in South Asia and Aid flow from UN agencies (US$) in Nicaragua?
Ensure brevity in your answer.  2.38e+08. In the year 1992, what is the difference between the Aid flow from UN agencies (US$) of South Asia and Aid flow from UN agencies (US$) of Togo?
Your answer should be compact. 2.45e+08. In the year 1992, what is the difference between the Aid flow from UN agencies (US$) in Nicaragua and Aid flow from UN agencies (US$) in Togo?
Provide a succinct answer. 7.40e+06. In the year 1993, what is the difference between the Aid flow from UN agencies (US$) of OECD members and Aid flow from UN agencies (US$) of South Asia?
Offer a terse response. -1.09e+08. In the year 1993, what is the difference between the Aid flow from UN agencies (US$) of OECD members and Aid flow from UN agencies (US$) of Nicaragua?
Offer a very short reply. 7.96e+06. In the year 1993, what is the difference between the Aid flow from UN agencies (US$) of OECD members and Aid flow from UN agencies (US$) of Togo?
Your response must be concise. 1.05e+07. In the year 1993, what is the difference between the Aid flow from UN agencies (US$) of South Asia and Aid flow from UN agencies (US$) of Nicaragua?
Your answer should be compact. 1.17e+08. In the year 1993, what is the difference between the Aid flow from UN agencies (US$) of South Asia and Aid flow from UN agencies (US$) of Togo?
Offer a very short reply. 1.19e+08. In the year 1993, what is the difference between the Aid flow from UN agencies (US$) in Nicaragua and Aid flow from UN agencies (US$) in Togo?
Your response must be concise. 2.51e+06. What is the ratio of the Aid flow from UN agencies (US$) of OECD members in 1987 to that in 1988?
Your answer should be very brief. 0.39. What is the ratio of the Aid flow from UN agencies (US$) of South Asia in 1987 to that in 1988?
Make the answer very short. 0.89. What is the ratio of the Aid flow from UN agencies (US$) of Nicaragua in 1987 to that in 1988?
Give a very brief answer. 0.45. What is the ratio of the Aid flow from UN agencies (US$) of Togo in 1987 to that in 1988?
Offer a terse response. 0.73. What is the ratio of the Aid flow from UN agencies (US$) of OECD members in 1987 to that in 1989?
Your answer should be compact. 0.81. What is the ratio of the Aid flow from UN agencies (US$) in South Asia in 1987 to that in 1989?
Your answer should be compact. 0.91. What is the ratio of the Aid flow from UN agencies (US$) in Nicaragua in 1987 to that in 1989?
Keep it short and to the point. 0.4. What is the ratio of the Aid flow from UN agencies (US$) in Togo in 1987 to that in 1989?
Provide a succinct answer. 0.75. What is the ratio of the Aid flow from UN agencies (US$) of OECD members in 1987 to that in 1990?
Ensure brevity in your answer.  0.19. What is the ratio of the Aid flow from UN agencies (US$) of South Asia in 1987 to that in 1990?
Make the answer very short. 0.92. What is the ratio of the Aid flow from UN agencies (US$) in Nicaragua in 1987 to that in 1990?
Provide a succinct answer. 0.62. What is the ratio of the Aid flow from UN agencies (US$) of Togo in 1987 to that in 1990?
Your answer should be compact. 0.9. What is the ratio of the Aid flow from UN agencies (US$) in OECD members in 1987 to that in 1991?
Your response must be concise. 0.84. What is the ratio of the Aid flow from UN agencies (US$) of South Asia in 1987 to that in 1991?
Provide a short and direct response. 0.83. What is the ratio of the Aid flow from UN agencies (US$) in Nicaragua in 1987 to that in 1991?
Your response must be concise. 0.66. What is the ratio of the Aid flow from UN agencies (US$) in Togo in 1987 to that in 1991?
Provide a short and direct response. 2.37. What is the ratio of the Aid flow from UN agencies (US$) in OECD members in 1987 to that in 1992?
Make the answer very short. 0.88. What is the ratio of the Aid flow from UN agencies (US$) in South Asia in 1987 to that in 1992?
Offer a very short reply. 0.69. What is the ratio of the Aid flow from UN agencies (US$) of Nicaragua in 1987 to that in 1992?
Make the answer very short. 0.54. What is the ratio of the Aid flow from UN agencies (US$) in Togo in 1987 to that in 1992?
Ensure brevity in your answer.  1.23. What is the ratio of the Aid flow from UN agencies (US$) in OECD members in 1987 to that in 1993?
Make the answer very short. 0.63. What is the ratio of the Aid flow from UN agencies (US$) of South Asia in 1987 to that in 1993?
Offer a very short reply. 1.42. What is the ratio of the Aid flow from UN agencies (US$) in Nicaragua in 1987 to that in 1993?
Your response must be concise. 1.6. What is the ratio of the Aid flow from UN agencies (US$) in Togo in 1987 to that in 1993?
Offer a terse response. 3.79. What is the ratio of the Aid flow from UN agencies (US$) in OECD members in 1988 to that in 1989?
Give a very brief answer. 2.07. What is the ratio of the Aid flow from UN agencies (US$) of Nicaragua in 1988 to that in 1989?
Ensure brevity in your answer.  0.89. What is the ratio of the Aid flow from UN agencies (US$) in Togo in 1988 to that in 1989?
Give a very brief answer. 1.02. What is the ratio of the Aid flow from UN agencies (US$) of OECD members in 1988 to that in 1990?
Your answer should be very brief. 0.48. What is the ratio of the Aid flow from UN agencies (US$) of South Asia in 1988 to that in 1990?
Offer a very short reply. 1.03. What is the ratio of the Aid flow from UN agencies (US$) of Nicaragua in 1988 to that in 1990?
Ensure brevity in your answer.  1.38. What is the ratio of the Aid flow from UN agencies (US$) in Togo in 1988 to that in 1990?
Keep it short and to the point. 1.24. What is the ratio of the Aid flow from UN agencies (US$) in OECD members in 1988 to that in 1991?
Your response must be concise. 2.14. What is the ratio of the Aid flow from UN agencies (US$) of South Asia in 1988 to that in 1991?
Provide a short and direct response. 0.93. What is the ratio of the Aid flow from UN agencies (US$) of Nicaragua in 1988 to that in 1991?
Give a very brief answer. 1.46. What is the ratio of the Aid flow from UN agencies (US$) in Togo in 1988 to that in 1991?
Offer a terse response. 3.25. What is the ratio of the Aid flow from UN agencies (US$) of OECD members in 1988 to that in 1992?
Keep it short and to the point. 2.23. What is the ratio of the Aid flow from UN agencies (US$) of South Asia in 1988 to that in 1992?
Your answer should be very brief. 0.77. What is the ratio of the Aid flow from UN agencies (US$) in Nicaragua in 1988 to that in 1992?
Give a very brief answer. 1.2. What is the ratio of the Aid flow from UN agencies (US$) in Togo in 1988 to that in 1992?
Provide a short and direct response. 1.69. What is the ratio of the Aid flow from UN agencies (US$) in OECD members in 1988 to that in 1993?
Provide a succinct answer. 1.61. What is the ratio of the Aid flow from UN agencies (US$) in South Asia in 1988 to that in 1993?
Give a very brief answer. 1.59. What is the ratio of the Aid flow from UN agencies (US$) in Nicaragua in 1988 to that in 1993?
Provide a short and direct response. 3.56. What is the ratio of the Aid flow from UN agencies (US$) of Togo in 1988 to that in 1993?
Ensure brevity in your answer.  5.19. What is the ratio of the Aid flow from UN agencies (US$) of OECD members in 1989 to that in 1990?
Offer a terse response. 0.23. What is the ratio of the Aid flow from UN agencies (US$) of South Asia in 1989 to that in 1990?
Offer a terse response. 1.02. What is the ratio of the Aid flow from UN agencies (US$) in Nicaragua in 1989 to that in 1990?
Give a very brief answer. 1.55. What is the ratio of the Aid flow from UN agencies (US$) in Togo in 1989 to that in 1990?
Provide a short and direct response. 1.21. What is the ratio of the Aid flow from UN agencies (US$) of OECD members in 1989 to that in 1991?
Give a very brief answer. 1.04. What is the ratio of the Aid flow from UN agencies (US$) of South Asia in 1989 to that in 1991?
Your answer should be compact. 0.91. What is the ratio of the Aid flow from UN agencies (US$) in Nicaragua in 1989 to that in 1991?
Keep it short and to the point. 1.65. What is the ratio of the Aid flow from UN agencies (US$) in Togo in 1989 to that in 1991?
Your response must be concise. 3.18. What is the ratio of the Aid flow from UN agencies (US$) in OECD members in 1989 to that in 1992?
Ensure brevity in your answer.  1.08. What is the ratio of the Aid flow from UN agencies (US$) of South Asia in 1989 to that in 1992?
Ensure brevity in your answer.  0.76. What is the ratio of the Aid flow from UN agencies (US$) in Nicaragua in 1989 to that in 1992?
Your response must be concise. 1.35. What is the ratio of the Aid flow from UN agencies (US$) of Togo in 1989 to that in 1992?
Keep it short and to the point. 1.65. What is the ratio of the Aid flow from UN agencies (US$) of OECD members in 1989 to that in 1993?
Your response must be concise. 0.78. What is the ratio of the Aid flow from UN agencies (US$) in South Asia in 1989 to that in 1993?
Your response must be concise. 1.56. What is the ratio of the Aid flow from UN agencies (US$) in Nicaragua in 1989 to that in 1993?
Give a very brief answer. 4.02. What is the ratio of the Aid flow from UN agencies (US$) of Togo in 1989 to that in 1993?
Make the answer very short. 5.07. What is the ratio of the Aid flow from UN agencies (US$) of OECD members in 1990 to that in 1991?
Your answer should be very brief. 4.49. What is the ratio of the Aid flow from UN agencies (US$) in South Asia in 1990 to that in 1991?
Your answer should be compact. 0.9. What is the ratio of the Aid flow from UN agencies (US$) of Nicaragua in 1990 to that in 1991?
Your answer should be very brief. 1.06. What is the ratio of the Aid flow from UN agencies (US$) of Togo in 1990 to that in 1991?
Offer a very short reply. 2.63. What is the ratio of the Aid flow from UN agencies (US$) of OECD members in 1990 to that in 1992?
Ensure brevity in your answer.  4.66. What is the ratio of the Aid flow from UN agencies (US$) of South Asia in 1990 to that in 1992?
Make the answer very short. 0.74. What is the ratio of the Aid flow from UN agencies (US$) in Nicaragua in 1990 to that in 1992?
Provide a short and direct response. 0.87. What is the ratio of the Aid flow from UN agencies (US$) in Togo in 1990 to that in 1992?
Keep it short and to the point. 1.36. What is the ratio of the Aid flow from UN agencies (US$) of OECD members in 1990 to that in 1993?
Provide a short and direct response. 3.37. What is the ratio of the Aid flow from UN agencies (US$) of South Asia in 1990 to that in 1993?
Ensure brevity in your answer.  1.54. What is the ratio of the Aid flow from UN agencies (US$) in Nicaragua in 1990 to that in 1993?
Your answer should be compact. 2.59. What is the ratio of the Aid flow from UN agencies (US$) of Togo in 1990 to that in 1993?
Offer a terse response. 4.19. What is the ratio of the Aid flow from UN agencies (US$) of OECD members in 1991 to that in 1992?
Offer a very short reply. 1.04. What is the ratio of the Aid flow from UN agencies (US$) in South Asia in 1991 to that in 1992?
Offer a terse response. 0.83. What is the ratio of the Aid flow from UN agencies (US$) in Nicaragua in 1991 to that in 1992?
Give a very brief answer. 0.82. What is the ratio of the Aid flow from UN agencies (US$) of Togo in 1991 to that in 1992?
Your answer should be very brief. 0.52. What is the ratio of the Aid flow from UN agencies (US$) of OECD members in 1991 to that in 1993?
Provide a succinct answer. 0.75. What is the ratio of the Aid flow from UN agencies (US$) of South Asia in 1991 to that in 1993?
Provide a short and direct response. 1.71. What is the ratio of the Aid flow from UN agencies (US$) in Nicaragua in 1991 to that in 1993?
Offer a very short reply. 2.43. What is the ratio of the Aid flow from UN agencies (US$) in Togo in 1991 to that in 1993?
Provide a short and direct response. 1.6. What is the ratio of the Aid flow from UN agencies (US$) in OECD members in 1992 to that in 1993?
Give a very brief answer. 0.72. What is the ratio of the Aid flow from UN agencies (US$) of South Asia in 1992 to that in 1993?
Your answer should be very brief. 2.06. What is the ratio of the Aid flow from UN agencies (US$) in Nicaragua in 1992 to that in 1993?
Offer a very short reply. 2.97. What is the ratio of the Aid flow from UN agencies (US$) in Togo in 1992 to that in 1993?
Provide a succinct answer. 3.07. What is the difference between the highest and the second highest Aid flow from UN agencies (US$) in OECD members?
Provide a succinct answer. 1.92e+07. What is the difference between the highest and the second highest Aid flow from UN agencies (US$) in South Asia?
Make the answer very short. 4.25e+07. What is the difference between the highest and the second highest Aid flow from UN agencies (US$) of Nicaragua?
Your response must be concise. 1.33e+06. What is the difference between the highest and the lowest Aid flow from UN agencies (US$) in OECD members?
Offer a terse response. 2.98e+07. What is the difference between the highest and the lowest Aid flow from UN agencies (US$) in South Asia?
Your response must be concise. 1.27e+08. What is the difference between the highest and the lowest Aid flow from UN agencies (US$) in Nicaragua?
Provide a short and direct response. 8.84e+06. What is the difference between the highest and the lowest Aid flow from UN agencies (US$) of Togo?
Your response must be concise. 1.76e+06. 